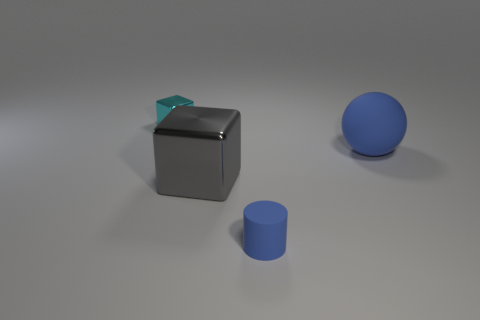What number of blocks are small gray rubber things or big gray objects?
Give a very brief answer. 1. How big is the blue object behind the shiny cube right of the small thing behind the rubber cylinder?
Give a very brief answer. Large. There is another thing that is the same size as the cyan object; what shape is it?
Provide a short and direct response. Cylinder. The small blue object has what shape?
Offer a terse response. Cylinder. Does the small object on the right side of the gray shiny thing have the same material as the gray thing?
Keep it short and to the point. No. How big is the cube in front of the block behind the large gray thing?
Provide a succinct answer. Large. There is a thing that is both to the right of the large metal cube and left of the large rubber thing; what color is it?
Make the answer very short. Blue. What is the material of the other thing that is the same size as the cyan metallic thing?
Offer a terse response. Rubber. How many other objects are there of the same material as the gray cube?
Your response must be concise. 1. There is a metal thing that is in front of the cyan shiny cube; is it the same color as the small object that is in front of the cyan thing?
Ensure brevity in your answer.  No. 